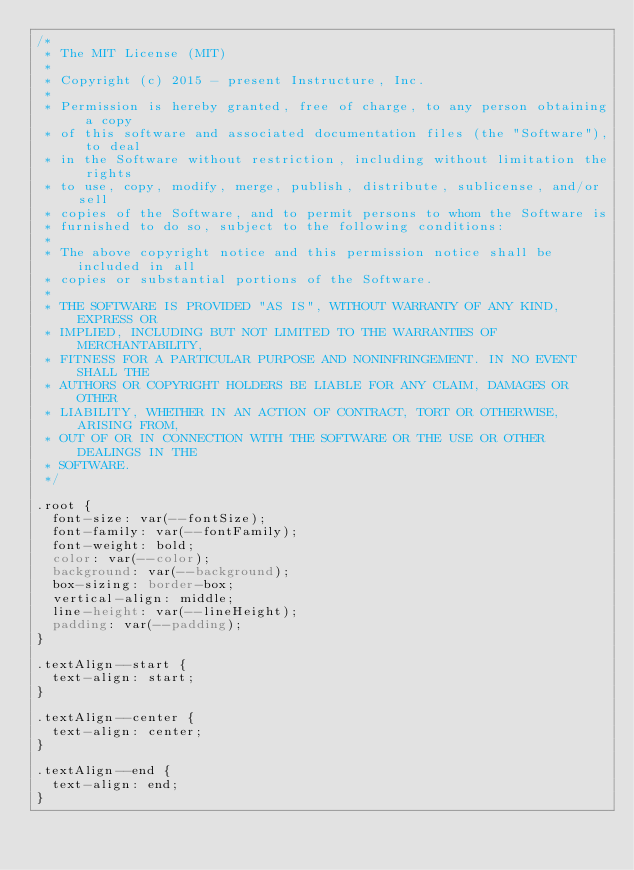Convert code to text. <code><loc_0><loc_0><loc_500><loc_500><_CSS_>/*
 * The MIT License (MIT)
 *
 * Copyright (c) 2015 - present Instructure, Inc.
 *
 * Permission is hereby granted, free of charge, to any person obtaining a copy
 * of this software and associated documentation files (the "Software"), to deal
 * in the Software without restriction, including without limitation the rights
 * to use, copy, modify, merge, publish, distribute, sublicense, and/or sell
 * copies of the Software, and to permit persons to whom the Software is
 * furnished to do so, subject to the following conditions:
 *
 * The above copyright notice and this permission notice shall be included in all
 * copies or substantial portions of the Software.
 *
 * THE SOFTWARE IS PROVIDED "AS IS", WITHOUT WARRANTY OF ANY KIND, EXPRESS OR
 * IMPLIED, INCLUDING BUT NOT LIMITED TO THE WARRANTIES OF MERCHANTABILITY,
 * FITNESS FOR A PARTICULAR PURPOSE AND NONINFRINGEMENT. IN NO EVENT SHALL THE
 * AUTHORS OR COPYRIGHT HOLDERS BE LIABLE FOR ANY CLAIM, DAMAGES OR OTHER
 * LIABILITY, WHETHER IN AN ACTION OF CONTRACT, TORT OR OTHERWISE, ARISING FROM,
 * OUT OF OR IN CONNECTION WITH THE SOFTWARE OR THE USE OR OTHER DEALINGS IN THE
 * SOFTWARE.
 */

.root {
  font-size: var(--fontSize);
  font-family: var(--fontFamily);
  font-weight: bold;
  color: var(--color);
  background: var(--background);
  box-sizing: border-box;
  vertical-align: middle;
  line-height: var(--lineHeight);
  padding: var(--padding);
}

.textAlign--start {
  text-align: start;
}

.textAlign--center {
  text-align: center;
}

.textAlign--end {
  text-align: end;
}
</code> 